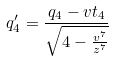Convert formula to latex. <formula><loc_0><loc_0><loc_500><loc_500>q _ { 4 } ^ { \prime } = \frac { q _ { 4 } - v t _ { 4 } } { \sqrt { 4 - \frac { v ^ { 7 } } { z ^ { 7 } } } }</formula> 